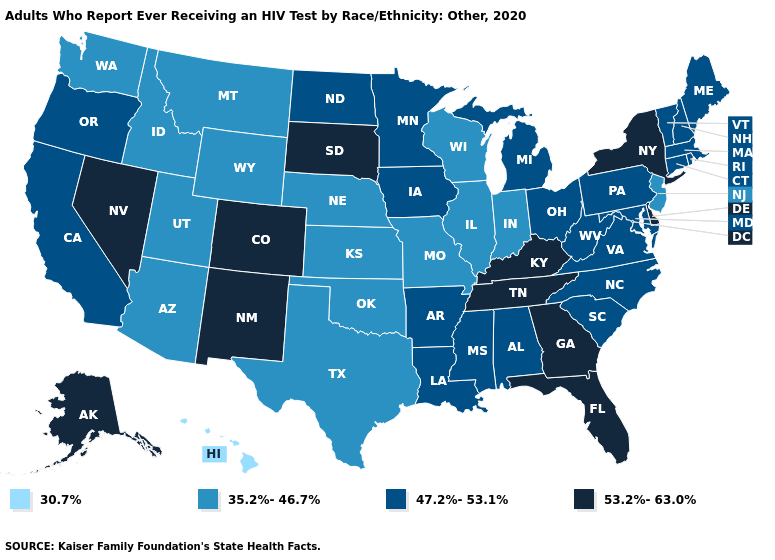Name the states that have a value in the range 35.2%-46.7%?
Be succinct. Arizona, Idaho, Illinois, Indiana, Kansas, Missouri, Montana, Nebraska, New Jersey, Oklahoma, Texas, Utah, Washington, Wisconsin, Wyoming. What is the highest value in states that border South Dakota?
Short answer required. 47.2%-53.1%. Name the states that have a value in the range 53.2%-63.0%?
Give a very brief answer. Alaska, Colorado, Delaware, Florida, Georgia, Kentucky, Nevada, New Mexico, New York, South Dakota, Tennessee. Does Tennessee have the highest value in the South?
Give a very brief answer. Yes. What is the value of Minnesota?
Be succinct. 47.2%-53.1%. What is the lowest value in the South?
Write a very short answer. 35.2%-46.7%. Among the states that border Mississippi , does Tennessee have the highest value?
Be succinct. Yes. Does South Carolina have the lowest value in the USA?
Concise answer only. No. What is the value of Iowa?
Give a very brief answer. 47.2%-53.1%. What is the value of Louisiana?
Be succinct. 47.2%-53.1%. Name the states that have a value in the range 47.2%-53.1%?
Keep it brief. Alabama, Arkansas, California, Connecticut, Iowa, Louisiana, Maine, Maryland, Massachusetts, Michigan, Minnesota, Mississippi, New Hampshire, North Carolina, North Dakota, Ohio, Oregon, Pennsylvania, Rhode Island, South Carolina, Vermont, Virginia, West Virginia. Name the states that have a value in the range 53.2%-63.0%?
Keep it brief. Alaska, Colorado, Delaware, Florida, Georgia, Kentucky, Nevada, New Mexico, New York, South Dakota, Tennessee. Which states hav the highest value in the MidWest?
Answer briefly. South Dakota. What is the value of Nebraska?
Be succinct. 35.2%-46.7%. 